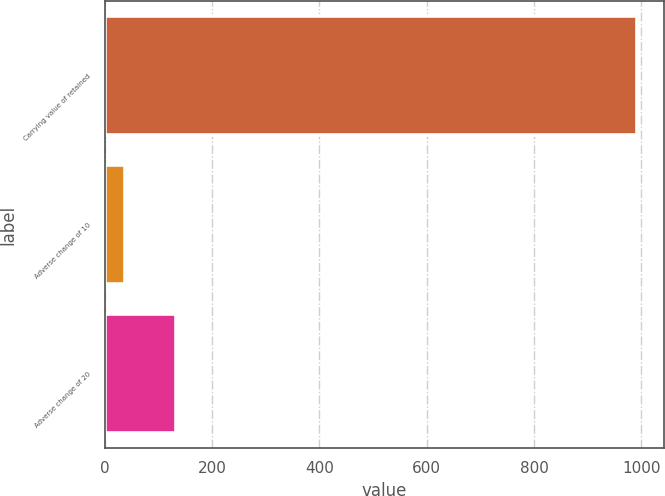Convert chart. <chart><loc_0><loc_0><loc_500><loc_500><bar_chart><fcel>Carrying value of retained<fcel>Adverse change of 10<fcel>Adverse change of 20<nl><fcel>992<fcel>38<fcel>133.4<nl></chart> 